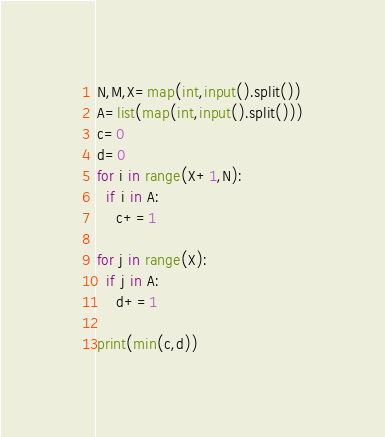<code> <loc_0><loc_0><loc_500><loc_500><_Python_>N,M,X=map(int,input().split())
A=list(map(int,input().split()))
c=0
d=0
for i in range(X+1,N):
  if i in A:
    c+=1

for j in range(X):
  if j in A:
    d+=1

print(min(c,d))</code> 